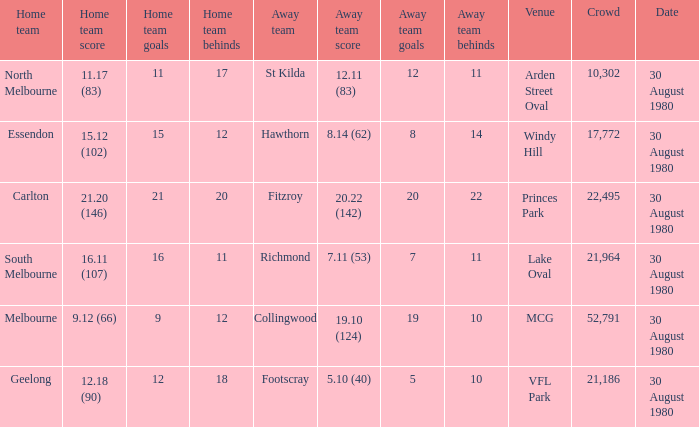What was the crowd when the away team is footscray? 21186.0. Parse the table in full. {'header': ['Home team', 'Home team score', 'Home team goals', 'Home team behinds', 'Away team', 'Away team score', 'Away team goals', 'Away team behinds', 'Venue', 'Crowd', 'Date'], 'rows': [['North Melbourne', '11.17 (83)', '11', '17', 'St Kilda', '12.11 (83)', '12', '11', 'Arden Street Oval', '10,302', '30 August 1980'], ['Essendon', '15.12 (102)', '15', '12', 'Hawthorn', '8.14 (62)', '8', '14', 'Windy Hill', '17,772', '30 August 1980'], ['Carlton', '21.20 (146)', '21', '20', 'Fitzroy', '20.22 (142)', '20', '22', 'Princes Park', '22,495', '30 August 1980'], ['South Melbourne', '16.11 (107)', '16', '11', 'Richmond', '7.11 (53)', '7', '11', 'Lake Oval', '21,964', '30 August 1980'], ['Melbourne', '9.12 (66)', '9', '12', 'Collingwood', '19.10 (124)', '19', '10', 'MCG', '52,791', '30 August 1980'], ['Geelong', '12.18 (90)', '12', '18', 'Footscray', '5.10 (40)', '5', '10', 'VFL Park', '21,186', '30 August 1980']]} 